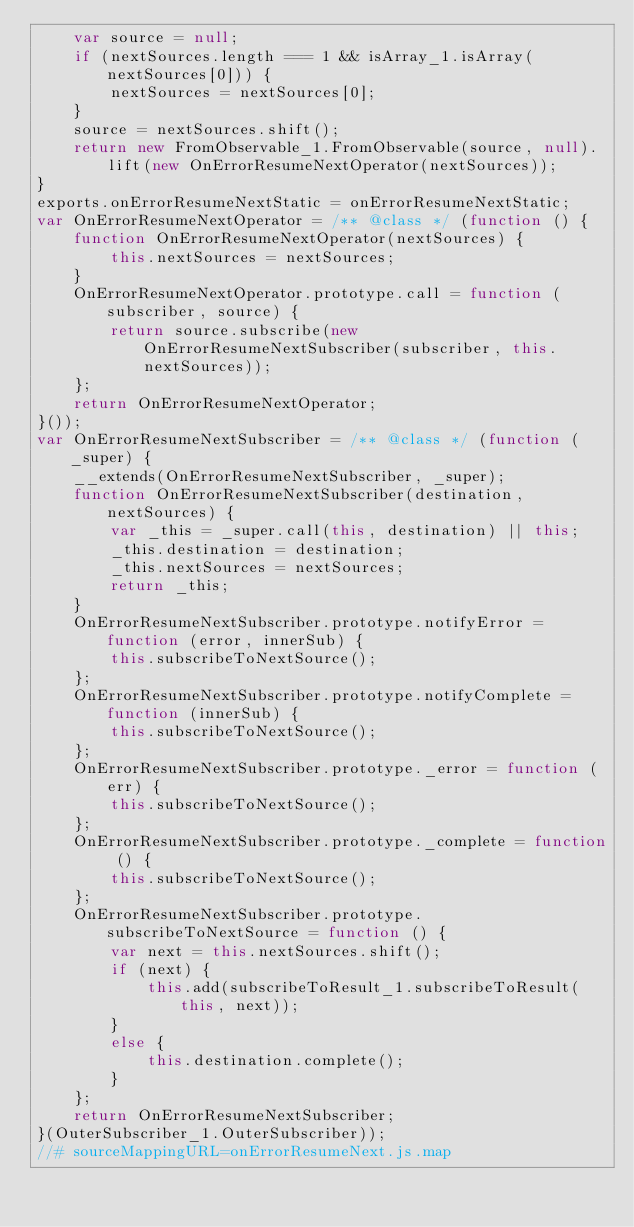<code> <loc_0><loc_0><loc_500><loc_500><_JavaScript_>    var source = null;
    if (nextSources.length === 1 && isArray_1.isArray(nextSources[0])) {
        nextSources = nextSources[0];
    }
    source = nextSources.shift();
    return new FromObservable_1.FromObservable(source, null).lift(new OnErrorResumeNextOperator(nextSources));
}
exports.onErrorResumeNextStatic = onErrorResumeNextStatic;
var OnErrorResumeNextOperator = /** @class */ (function () {
    function OnErrorResumeNextOperator(nextSources) {
        this.nextSources = nextSources;
    }
    OnErrorResumeNextOperator.prototype.call = function (subscriber, source) {
        return source.subscribe(new OnErrorResumeNextSubscriber(subscriber, this.nextSources));
    };
    return OnErrorResumeNextOperator;
}());
var OnErrorResumeNextSubscriber = /** @class */ (function (_super) {
    __extends(OnErrorResumeNextSubscriber, _super);
    function OnErrorResumeNextSubscriber(destination, nextSources) {
        var _this = _super.call(this, destination) || this;
        _this.destination = destination;
        _this.nextSources = nextSources;
        return _this;
    }
    OnErrorResumeNextSubscriber.prototype.notifyError = function (error, innerSub) {
        this.subscribeToNextSource();
    };
    OnErrorResumeNextSubscriber.prototype.notifyComplete = function (innerSub) {
        this.subscribeToNextSource();
    };
    OnErrorResumeNextSubscriber.prototype._error = function (err) {
        this.subscribeToNextSource();
    };
    OnErrorResumeNextSubscriber.prototype._complete = function () {
        this.subscribeToNextSource();
    };
    OnErrorResumeNextSubscriber.prototype.subscribeToNextSource = function () {
        var next = this.nextSources.shift();
        if (next) {
            this.add(subscribeToResult_1.subscribeToResult(this, next));
        }
        else {
            this.destination.complete();
        }
    };
    return OnErrorResumeNextSubscriber;
}(OuterSubscriber_1.OuterSubscriber));
//# sourceMappingURL=onErrorResumeNext.js.map</code> 